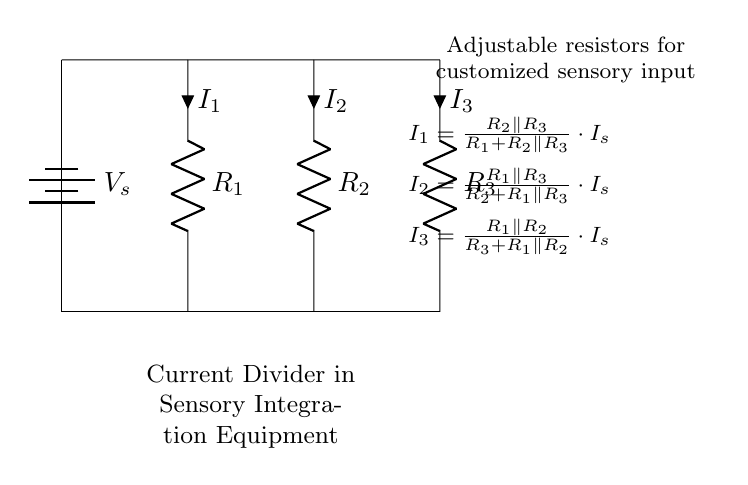What are the components in this circuit? The components include a voltage source and three resistors. Each component is visibly represented in the circuit diagram, with clear labels for the resistors.
Answer: Voltage source, three resistors What is the total current entering the circuit? The total current, denoted as I_s, is the incoming current represented at the source of the circuit. Since there are no branching paths before this point, the total current is simply the current from the source.
Answer: I_s How many branches does the current divide into? The circuit has three resistors connected in parallel, which creates three distinct branches for the current to flow through.
Answer: Three branches What happens to the current if one resistor is removed? Removing one resistor would change the total resistance, and thus the current distribution among the remaining resistors. Using the current divider formula, the current through the remaining resistors would increase, as they'd experience a larger share of the current.
Answer: Current increases in remaining resistors What is the equation for current I_1? The equation for current I_1 is given as the ratio of the parallel combination of R_2 and R_3 with the sum of the resistance R_1 and the parallel combination, multiplied by the source current I_s. Specifically, it is expressed mathematically in the provided schematic.
Answer: I_1 = (R_2 parallel R_3)/(R_1 + (R_2 parallel R_3)) * I_s Which components are adjustable? The circuit diagram indicates that the resistors are adjustable, allowing customization of the sensory input, essential for tailoring the equipment to the user's needs.
Answer: Resistors 